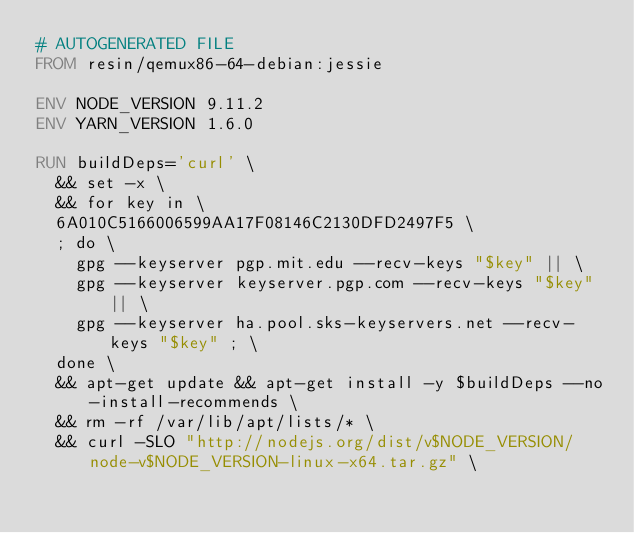<code> <loc_0><loc_0><loc_500><loc_500><_Dockerfile_># AUTOGENERATED FILE
FROM resin/qemux86-64-debian:jessie

ENV NODE_VERSION 9.11.2
ENV YARN_VERSION 1.6.0

RUN buildDeps='curl' \
	&& set -x \
	&& for key in \
	6A010C5166006599AA17F08146C2130DFD2497F5 \
	; do \
		gpg --keyserver pgp.mit.edu --recv-keys "$key" || \
		gpg --keyserver keyserver.pgp.com --recv-keys "$key" || \
		gpg --keyserver ha.pool.sks-keyservers.net --recv-keys "$key" ; \
	done \
	&& apt-get update && apt-get install -y $buildDeps --no-install-recommends \
	&& rm -rf /var/lib/apt/lists/* \
	&& curl -SLO "http://nodejs.org/dist/v$NODE_VERSION/node-v$NODE_VERSION-linux-x64.tar.gz" \</code> 